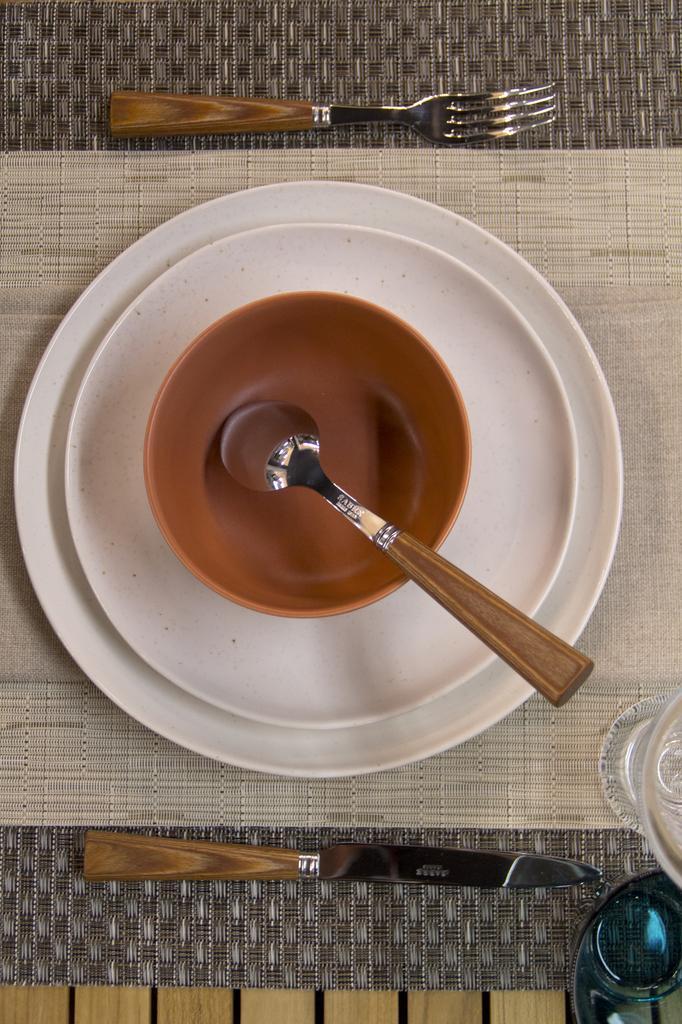Could you give a brief overview of what you see in this image? In this image we can see a spoon in a bowl in the plates, knife, fork and glasses are on a platform. 